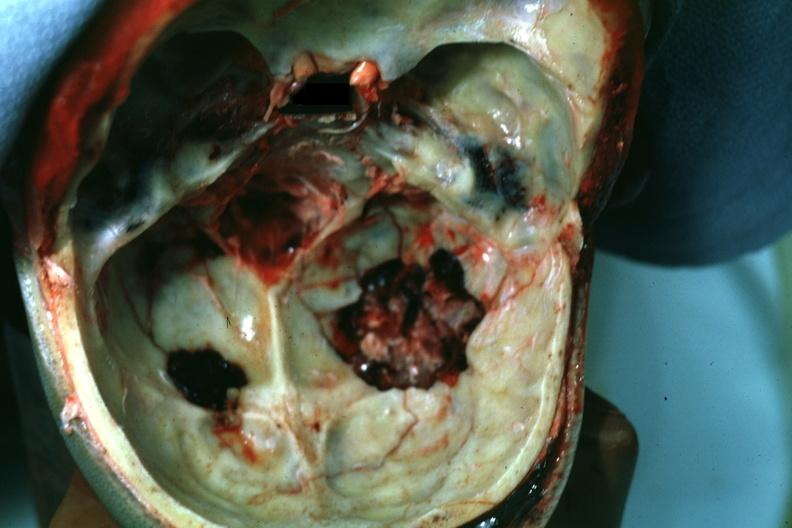what is present?
Answer the question using a single word or phrase. Bone 